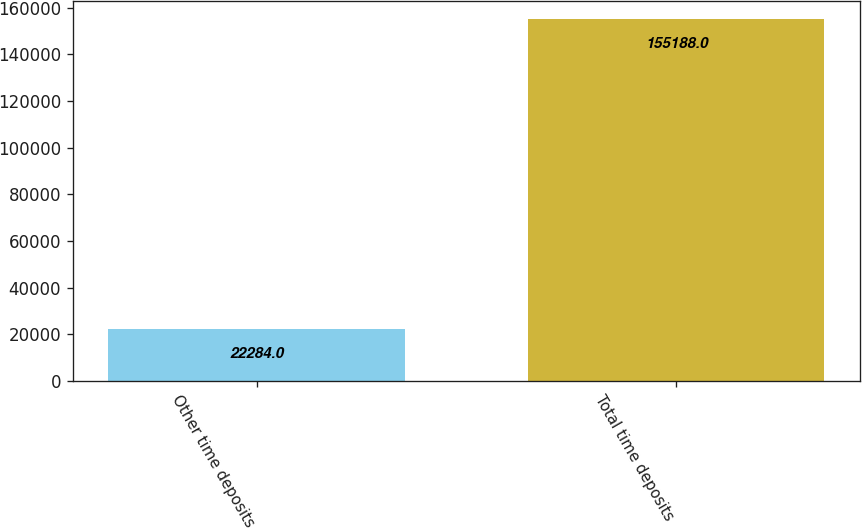Convert chart to OTSL. <chart><loc_0><loc_0><loc_500><loc_500><bar_chart><fcel>Other time deposits<fcel>Total time deposits<nl><fcel>22284<fcel>155188<nl></chart> 